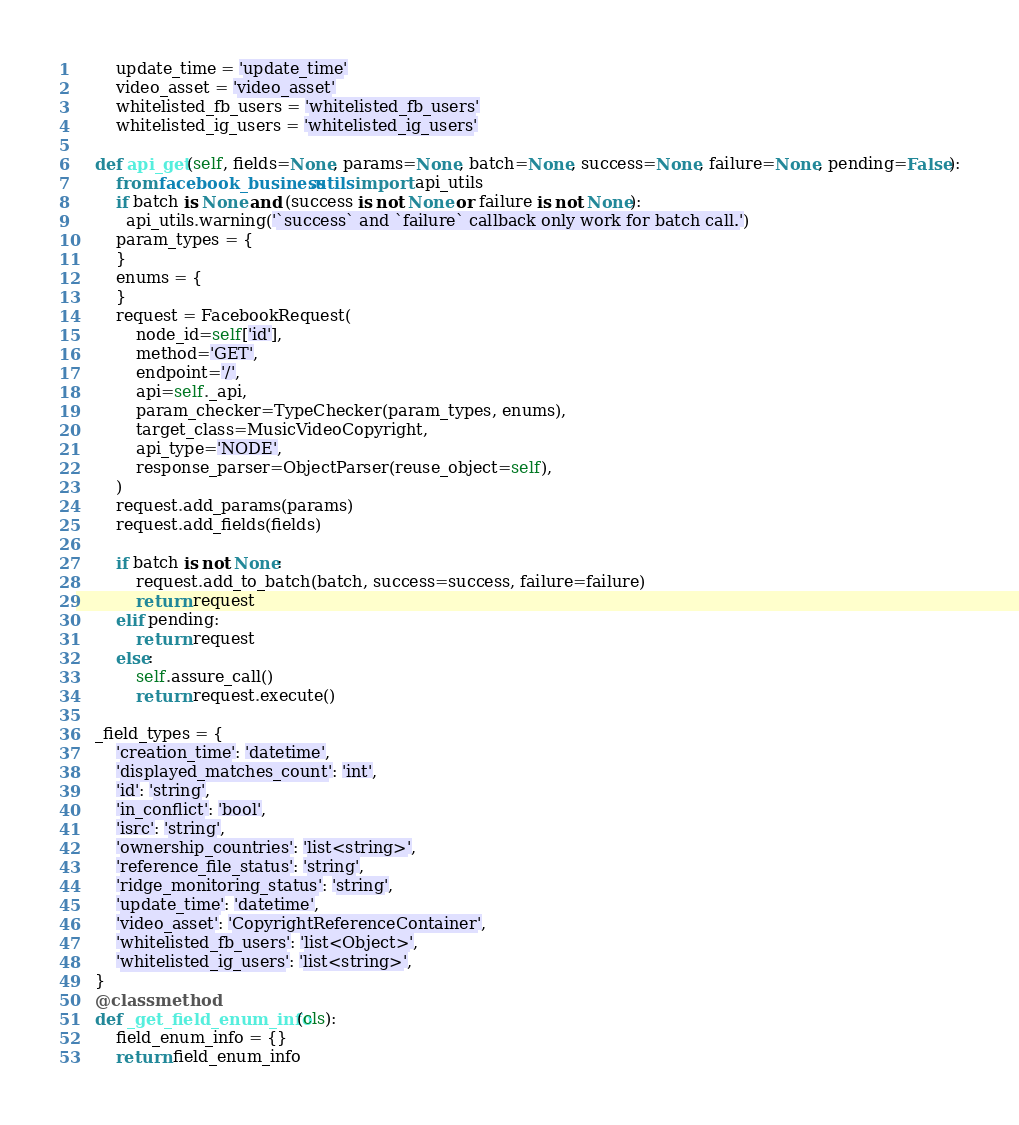<code> <loc_0><loc_0><loc_500><loc_500><_Python_>        update_time = 'update_time'
        video_asset = 'video_asset'
        whitelisted_fb_users = 'whitelisted_fb_users'
        whitelisted_ig_users = 'whitelisted_ig_users'

    def api_get(self, fields=None, params=None, batch=None, success=None, failure=None, pending=False):
        from facebook_business.utils import api_utils
        if batch is None and (success is not None or failure is not None):
          api_utils.warning('`success` and `failure` callback only work for batch call.')
        param_types = {
        }
        enums = {
        }
        request = FacebookRequest(
            node_id=self['id'],
            method='GET',
            endpoint='/',
            api=self._api,
            param_checker=TypeChecker(param_types, enums),
            target_class=MusicVideoCopyright,
            api_type='NODE',
            response_parser=ObjectParser(reuse_object=self),
        )
        request.add_params(params)
        request.add_fields(fields)

        if batch is not None:
            request.add_to_batch(batch, success=success, failure=failure)
            return request
        elif pending:
            return request
        else:
            self.assure_call()
            return request.execute()

    _field_types = {
        'creation_time': 'datetime',
        'displayed_matches_count': 'int',
        'id': 'string',
        'in_conflict': 'bool',
        'isrc': 'string',
        'ownership_countries': 'list<string>',
        'reference_file_status': 'string',
        'ridge_monitoring_status': 'string',
        'update_time': 'datetime',
        'video_asset': 'CopyrightReferenceContainer',
        'whitelisted_fb_users': 'list<Object>',
        'whitelisted_ig_users': 'list<string>',
    }
    @classmethod
    def _get_field_enum_info(cls):
        field_enum_info = {}
        return field_enum_info


</code> 